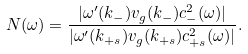<formula> <loc_0><loc_0><loc_500><loc_500>N ( \omega ) = \frac { | \omega ^ { \prime } ( k _ { - } ) v _ { g } ( k _ { - } ) c _ { - } ^ { 2 } ( \omega ) | } { | \omega ^ { \prime } ( k _ { + s } ) v _ { g } ( k _ { + s } ) c _ { + s } ^ { 2 } ( \omega ) | } .</formula> 